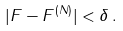<formula> <loc_0><loc_0><loc_500><loc_500>| F - F ^ { ( N ) } | < \delta \, .</formula> 